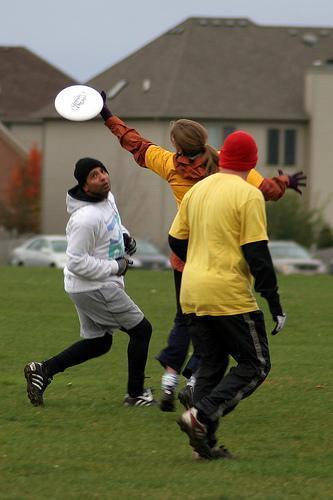How many people are visible?
Give a very brief answer. 3. How many girls are there?
Give a very brief answer. 1. How many guys are there?
Give a very brief answer. 2. 